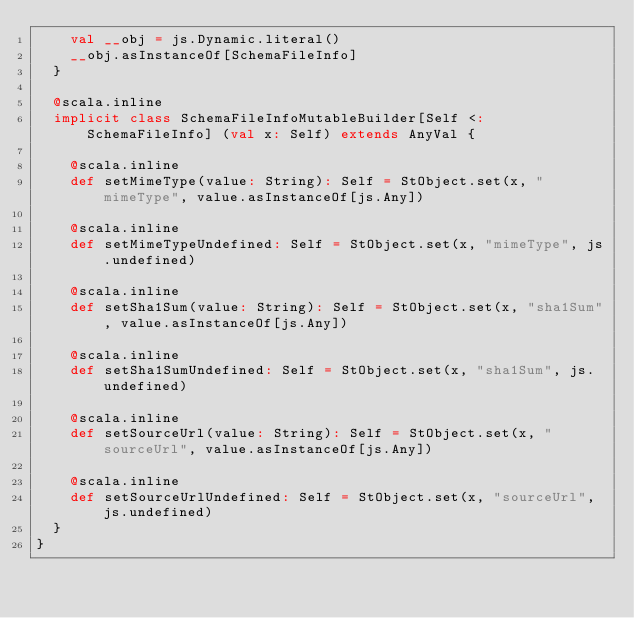Convert code to text. <code><loc_0><loc_0><loc_500><loc_500><_Scala_>    val __obj = js.Dynamic.literal()
    __obj.asInstanceOf[SchemaFileInfo]
  }
  
  @scala.inline
  implicit class SchemaFileInfoMutableBuilder[Self <: SchemaFileInfo] (val x: Self) extends AnyVal {
    
    @scala.inline
    def setMimeType(value: String): Self = StObject.set(x, "mimeType", value.asInstanceOf[js.Any])
    
    @scala.inline
    def setMimeTypeUndefined: Self = StObject.set(x, "mimeType", js.undefined)
    
    @scala.inline
    def setSha1Sum(value: String): Self = StObject.set(x, "sha1Sum", value.asInstanceOf[js.Any])
    
    @scala.inline
    def setSha1SumUndefined: Self = StObject.set(x, "sha1Sum", js.undefined)
    
    @scala.inline
    def setSourceUrl(value: String): Self = StObject.set(x, "sourceUrl", value.asInstanceOf[js.Any])
    
    @scala.inline
    def setSourceUrlUndefined: Self = StObject.set(x, "sourceUrl", js.undefined)
  }
}
</code> 